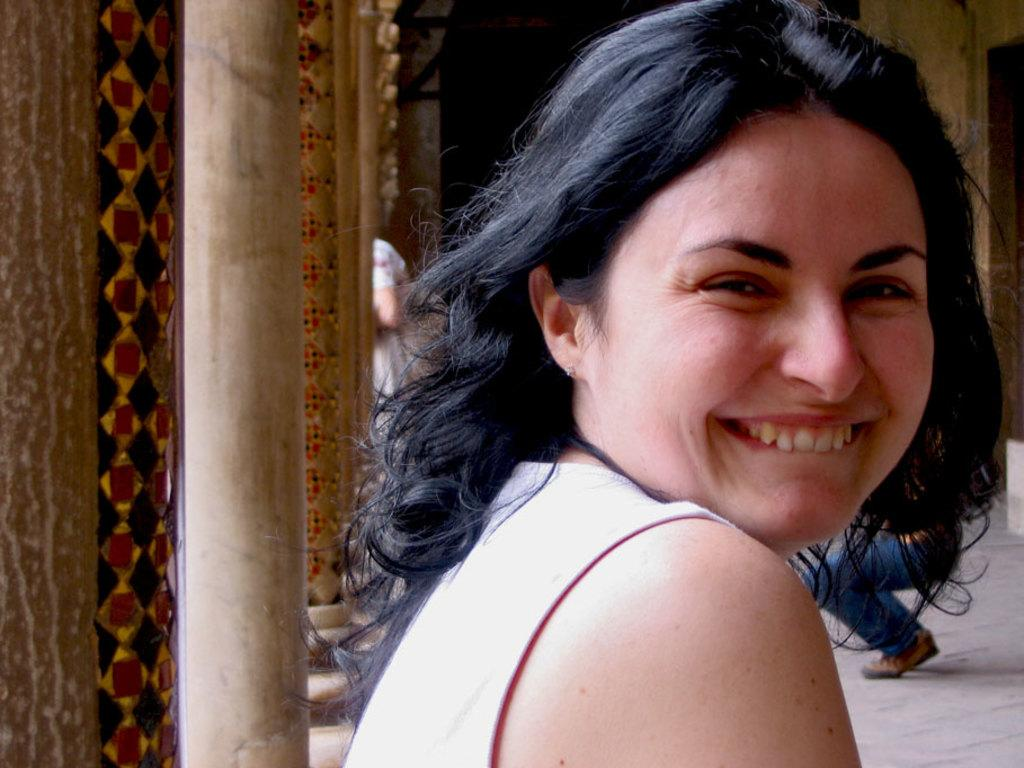Who is the main subject in the image? There is a woman in the image. What is the woman doing in the image? The woman is smiling and posing for the picture. What can be seen on the left side of the image? There are poles on the left side of the image. Are there any other people visible in the image? Yes, there are more people visible in the background of the image. What type of eggs are being used to rest on the poles in the image? There are no eggs present in the image, and the poles are not being used for resting. 